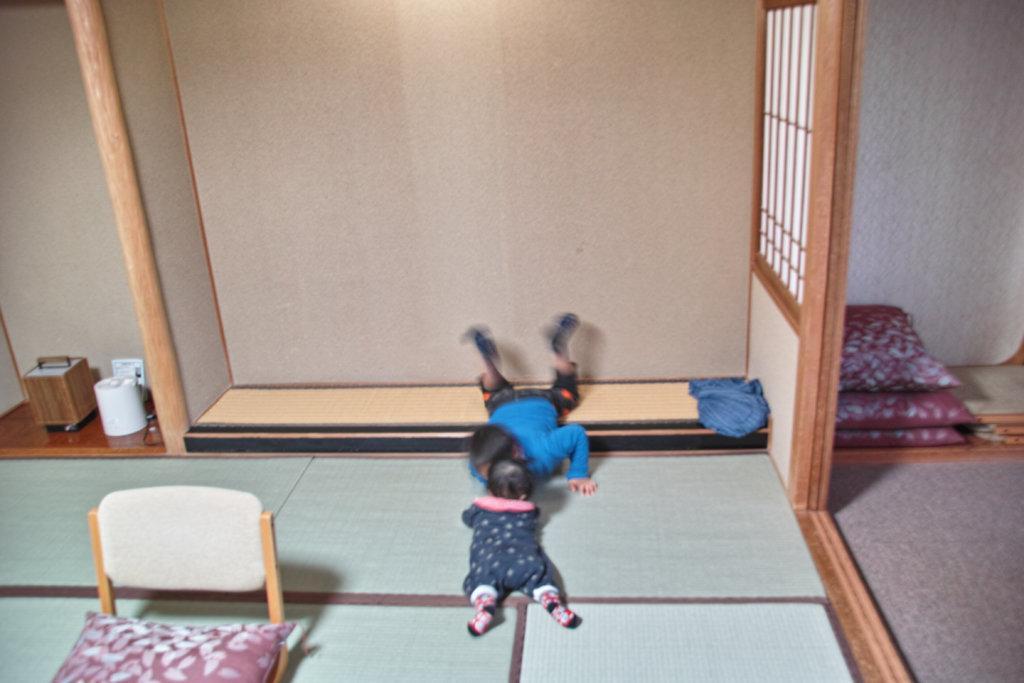Can you describe this image briefly? In this image there are two children's laying on the floor, there is a chair, there are two objects and on the right side of the image there are two pillows and in the background there is a wall. 